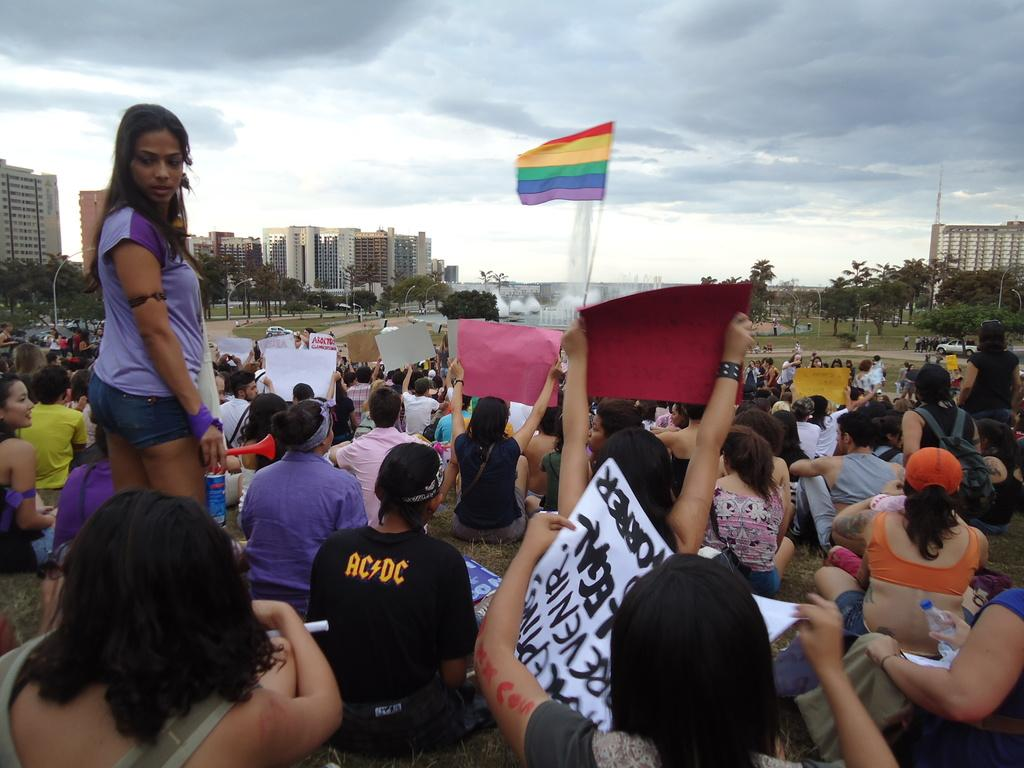What are the people in the image doing? The people in the image are sitting on the ground, holding banners. What is in front of the people? There is a flag and a fountain in front of the people. What can be seen in the background of the image? There are trees, at least one building, and the sky visible in the background of the image. What type of sweater is the person wearing in the image? There is no person wearing a sweater in the image; the people are sitting on the ground and holding banners. 